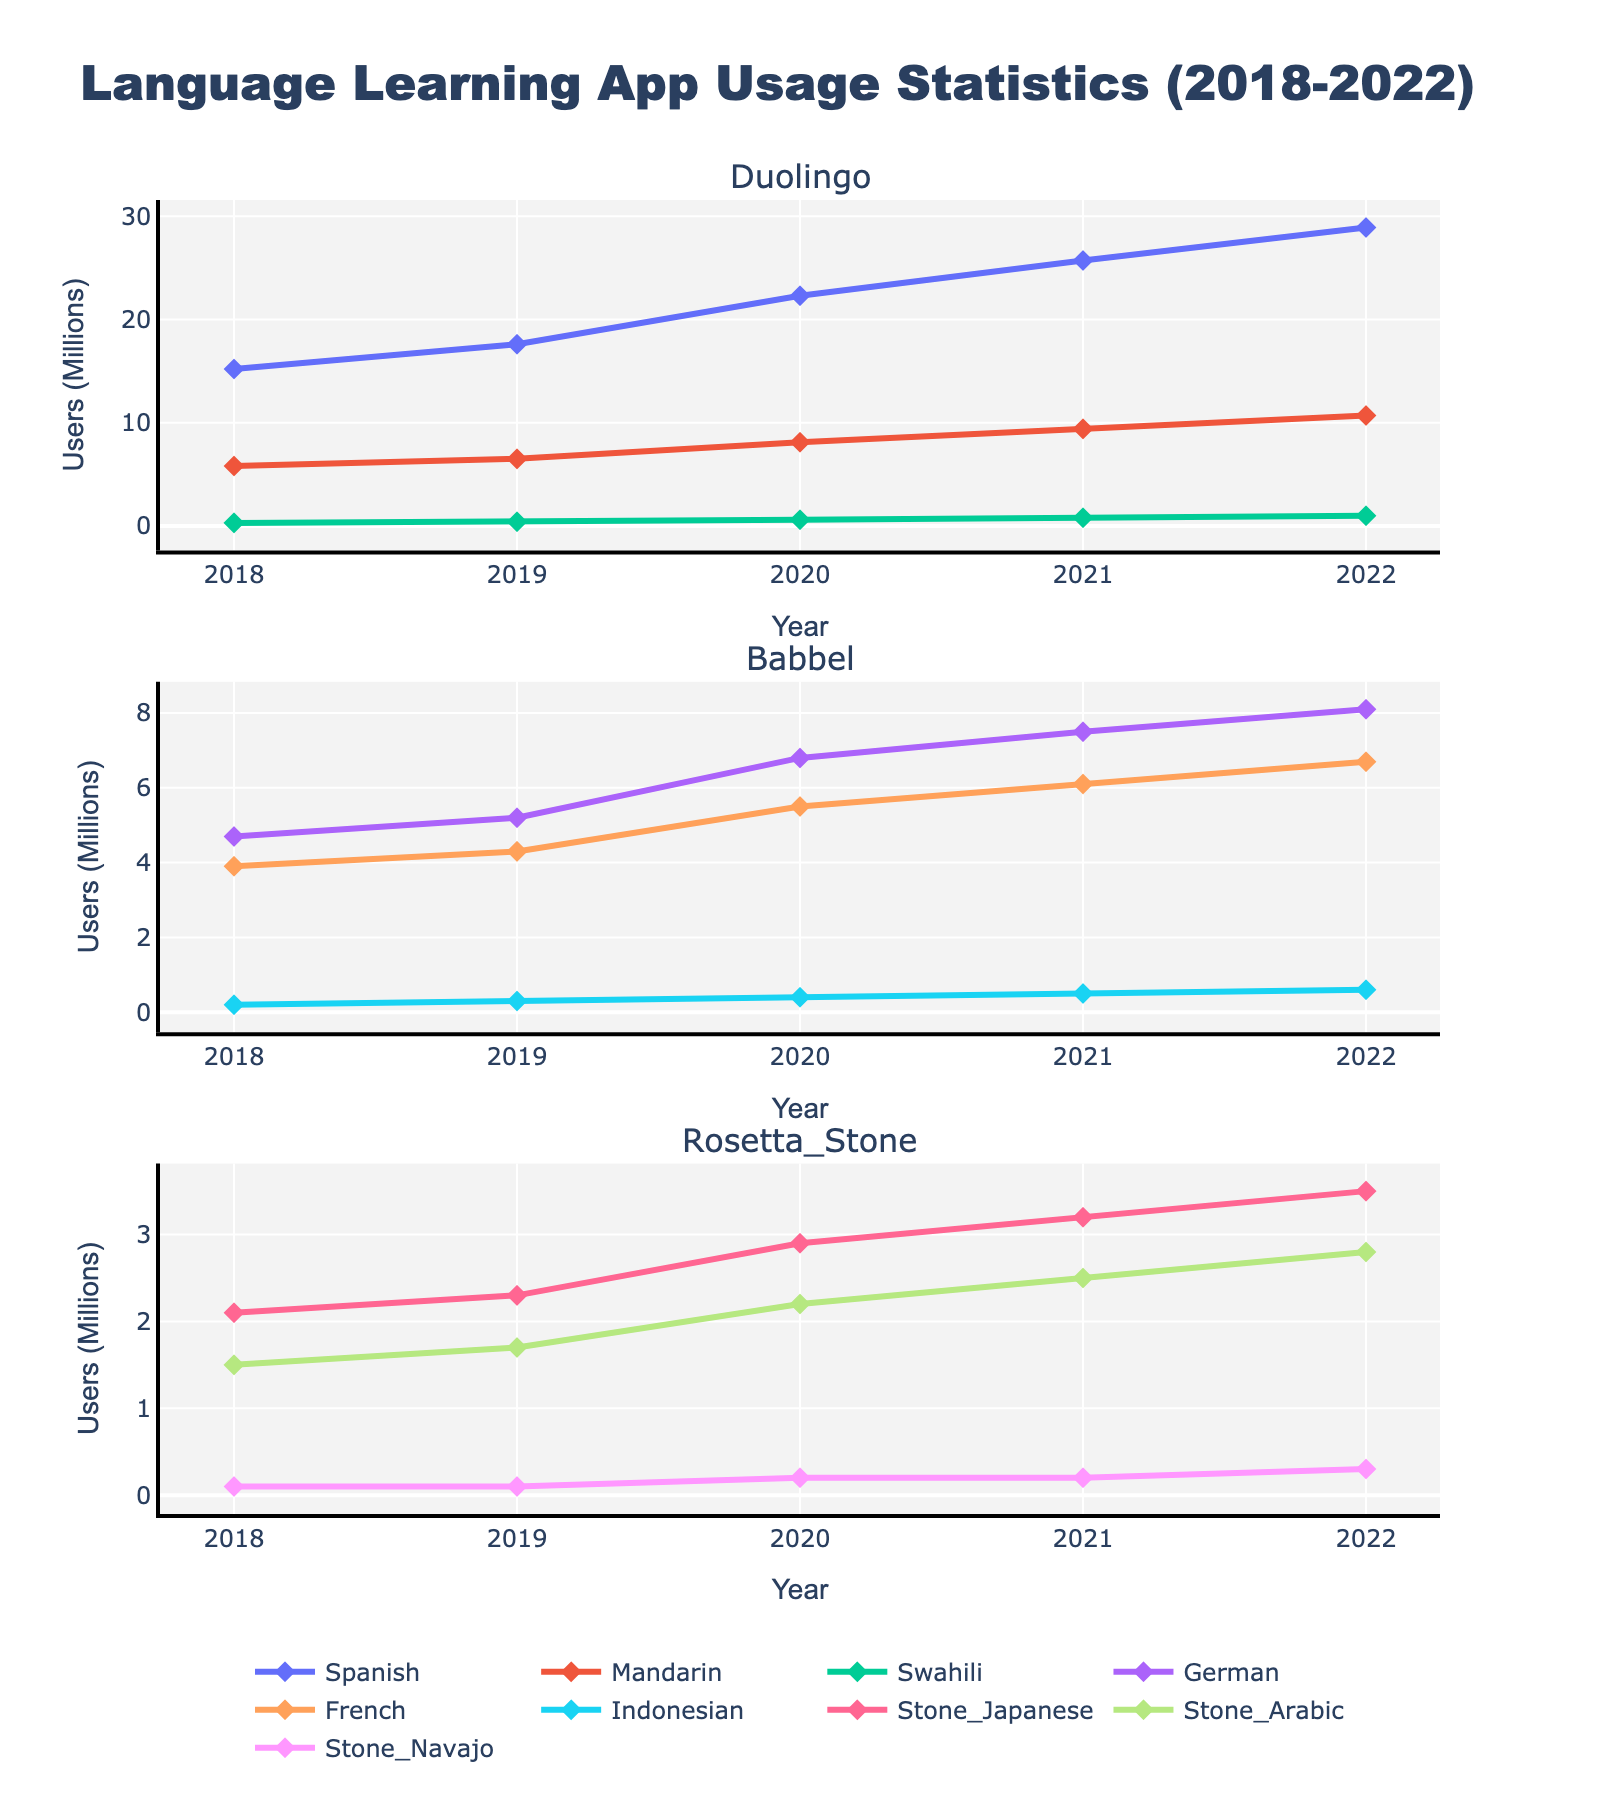What's the title of the figure? The title of the figure is located at the top and is usually in larger font size compared to other text in the figure. In this case, the title is "Language Learning App Usage Statistics (2018-2022)".
Answer: Language Learning App Usage Statistics (2018-2022) Which language has the highest number of users in 2022 on Duolingo? To find this, look at the Duolingo subplot and identify the line that reaches the highest point on the y-axis in 2022. That line represents Spanish.
Answer: Spanish What was the total number of users for Spanish on Duolingo across all years? Sum the values for Spanish on Duolingo for each year: 15.2 (2018) + 17.6 (2019) + 22.3 (2020) + 25.7 (2021) + 28.9 (2022). This adds up to 109.7.
Answer: 109.7 million Compare the trends of Swahili on Duolingo and Navajo on Rosetta Stone. Which language shows a higher growth rate? Look at the slopes and lengths of the lines representing Swahili and Navajo from 2018 to 2022. Swahili starts at 0.3 and ends at 1.0, while Navajo starts at 0.1 and ends at 0.3. Swahili shows a higher growth rate.
Answer: Swahili Among the languages listed for Babbel, which language had the smallest user base in 2020? In the Babbel subplot, find the data points for each language in the year 2020. Compare the heights on the y-axis. Indonesian had the smallest user base at 0.4 million users.
Answer: Indonesian What is the increase in the number of users for Mandarin on Duolingo from 2018 to 2022? Subtract the number of users in 2018 (5.8) from the number in 2022 (10.7). The increase is 10.7 - 5.8 = 4.9 million users.
Answer: 4.9 million Which app shows the most diversified language offering based on the chart? Count the number of different languages offered by each app in their respective subplots. Rosetta Stone offers the most languages with 3 options: Japanese, Arabic, and Navajo.
Answer: Rosetta Stone How did the number of users for French on Babbel change from 2019 to 2021? Look at the y-values of the data points for French on Babbel in 2019 and 2021. In 2019, it was 4.3 million, and in 2021, it was 6.1 million. The change is 6.1 - 4.3 = 1.8 million users.
Answer: Increased by 1.8 million What is the average number of users for Japanese on Rosetta Stone across all years? Sum the values for Japanese on Rosetta Stone for each year and then divide by the number of years. (2.1 + 2.3 + 2.9 + 3.2 + 3.5) / 5 = 14.0 / 5 = 2.8 million users.
Answer: 2.8 million 